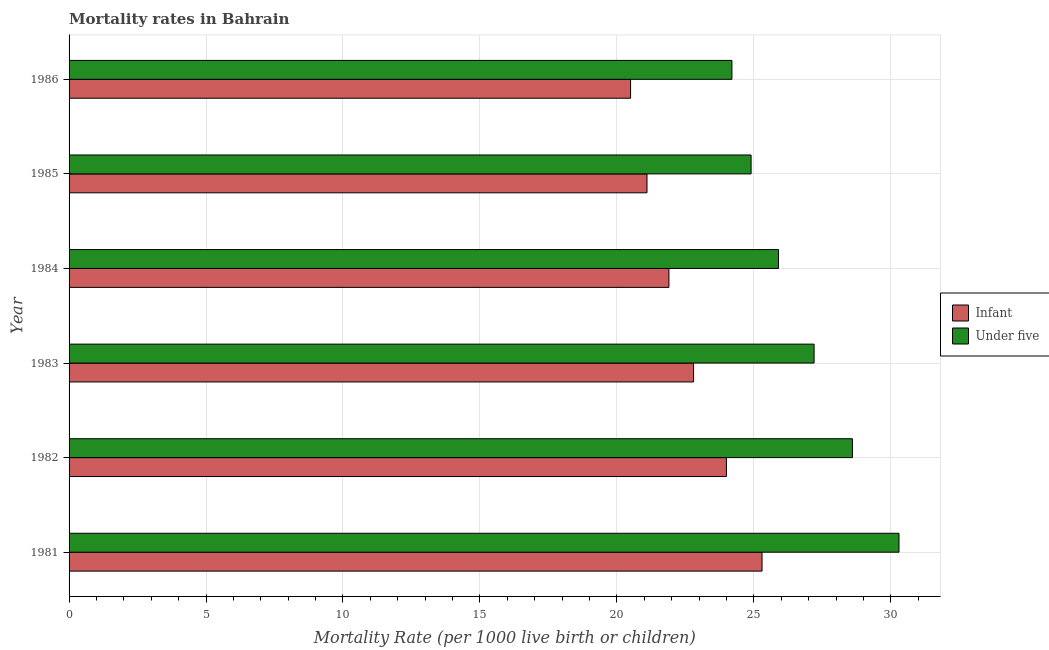How many different coloured bars are there?
Offer a terse response. 2. Are the number of bars per tick equal to the number of legend labels?
Offer a very short reply. Yes. Are the number of bars on each tick of the Y-axis equal?
Ensure brevity in your answer.  Yes. What is the label of the 5th group of bars from the top?
Provide a short and direct response. 1982. What is the under-5 mortality rate in 1982?
Offer a terse response. 28.6. Across all years, what is the maximum infant mortality rate?
Provide a short and direct response. 25.3. Across all years, what is the minimum under-5 mortality rate?
Your response must be concise. 24.2. In which year was the infant mortality rate maximum?
Make the answer very short. 1981. In which year was the under-5 mortality rate minimum?
Make the answer very short. 1986. What is the total infant mortality rate in the graph?
Make the answer very short. 135.6. What is the difference between the under-5 mortality rate in 1985 and that in 1986?
Provide a short and direct response. 0.7. What is the difference between the under-5 mortality rate in 1984 and the infant mortality rate in 1982?
Your answer should be very brief. 1.9. What is the average infant mortality rate per year?
Make the answer very short. 22.6. In how many years, is the infant mortality rate greater than 20 ?
Give a very brief answer. 6. What is the ratio of the infant mortality rate in 1981 to that in 1982?
Your answer should be very brief. 1.05. What is the difference between the highest and the second highest infant mortality rate?
Your response must be concise. 1.3. Is the sum of the infant mortality rate in 1983 and 1985 greater than the maximum under-5 mortality rate across all years?
Offer a very short reply. Yes. What does the 2nd bar from the top in 1981 represents?
Your answer should be compact. Infant. What does the 1st bar from the bottom in 1986 represents?
Give a very brief answer. Infant. What is the difference between two consecutive major ticks on the X-axis?
Make the answer very short. 5. Are the values on the major ticks of X-axis written in scientific E-notation?
Your answer should be compact. No. Does the graph contain grids?
Provide a short and direct response. Yes. Where does the legend appear in the graph?
Provide a succinct answer. Center right. How are the legend labels stacked?
Give a very brief answer. Vertical. What is the title of the graph?
Provide a short and direct response. Mortality rates in Bahrain. What is the label or title of the X-axis?
Your answer should be very brief. Mortality Rate (per 1000 live birth or children). What is the Mortality Rate (per 1000 live birth or children) of Infant in 1981?
Your response must be concise. 25.3. What is the Mortality Rate (per 1000 live birth or children) of Under five in 1981?
Ensure brevity in your answer.  30.3. What is the Mortality Rate (per 1000 live birth or children) of Infant in 1982?
Provide a succinct answer. 24. What is the Mortality Rate (per 1000 live birth or children) of Under five in 1982?
Your response must be concise. 28.6. What is the Mortality Rate (per 1000 live birth or children) in Infant in 1983?
Your answer should be very brief. 22.8. What is the Mortality Rate (per 1000 live birth or children) in Under five in 1983?
Ensure brevity in your answer.  27.2. What is the Mortality Rate (per 1000 live birth or children) of Infant in 1984?
Provide a succinct answer. 21.9. What is the Mortality Rate (per 1000 live birth or children) in Under five in 1984?
Make the answer very short. 25.9. What is the Mortality Rate (per 1000 live birth or children) in Infant in 1985?
Your answer should be very brief. 21.1. What is the Mortality Rate (per 1000 live birth or children) of Under five in 1985?
Keep it short and to the point. 24.9. What is the Mortality Rate (per 1000 live birth or children) of Under five in 1986?
Your answer should be very brief. 24.2. Across all years, what is the maximum Mortality Rate (per 1000 live birth or children) in Infant?
Make the answer very short. 25.3. Across all years, what is the maximum Mortality Rate (per 1000 live birth or children) in Under five?
Provide a succinct answer. 30.3. Across all years, what is the minimum Mortality Rate (per 1000 live birth or children) of Infant?
Ensure brevity in your answer.  20.5. Across all years, what is the minimum Mortality Rate (per 1000 live birth or children) in Under five?
Make the answer very short. 24.2. What is the total Mortality Rate (per 1000 live birth or children) in Infant in the graph?
Provide a succinct answer. 135.6. What is the total Mortality Rate (per 1000 live birth or children) in Under five in the graph?
Provide a short and direct response. 161.1. What is the difference between the Mortality Rate (per 1000 live birth or children) of Under five in 1981 and that in 1984?
Provide a succinct answer. 4.4. What is the difference between the Mortality Rate (per 1000 live birth or children) in Infant in 1981 and that in 1985?
Give a very brief answer. 4.2. What is the difference between the Mortality Rate (per 1000 live birth or children) in Infant in 1981 and that in 1986?
Give a very brief answer. 4.8. What is the difference between the Mortality Rate (per 1000 live birth or children) in Infant in 1982 and that in 1984?
Your answer should be compact. 2.1. What is the difference between the Mortality Rate (per 1000 live birth or children) in Under five in 1982 and that in 1984?
Provide a short and direct response. 2.7. What is the difference between the Mortality Rate (per 1000 live birth or children) in Under five in 1982 and that in 1985?
Your answer should be very brief. 3.7. What is the difference between the Mortality Rate (per 1000 live birth or children) of Infant in 1983 and that in 1984?
Your response must be concise. 0.9. What is the difference between the Mortality Rate (per 1000 live birth or children) in Infant in 1983 and that in 1985?
Provide a short and direct response. 1.7. What is the difference between the Mortality Rate (per 1000 live birth or children) of Under five in 1983 and that in 1986?
Give a very brief answer. 3. What is the difference between the Mortality Rate (per 1000 live birth or children) in Infant in 1984 and that in 1986?
Your answer should be very brief. 1.4. What is the difference between the Mortality Rate (per 1000 live birth or children) in Under five in 1984 and that in 1986?
Offer a very short reply. 1.7. What is the difference between the Mortality Rate (per 1000 live birth or children) in Under five in 1985 and that in 1986?
Your response must be concise. 0.7. What is the difference between the Mortality Rate (per 1000 live birth or children) in Infant in 1981 and the Mortality Rate (per 1000 live birth or children) in Under five in 1982?
Provide a short and direct response. -3.3. What is the difference between the Mortality Rate (per 1000 live birth or children) of Infant in 1981 and the Mortality Rate (per 1000 live birth or children) of Under five in 1985?
Give a very brief answer. 0.4. What is the difference between the Mortality Rate (per 1000 live birth or children) of Infant in 1982 and the Mortality Rate (per 1000 live birth or children) of Under five in 1984?
Your response must be concise. -1.9. What is the difference between the Mortality Rate (per 1000 live birth or children) in Infant in 1982 and the Mortality Rate (per 1000 live birth or children) in Under five in 1985?
Make the answer very short. -0.9. What is the difference between the Mortality Rate (per 1000 live birth or children) in Infant in 1982 and the Mortality Rate (per 1000 live birth or children) in Under five in 1986?
Your answer should be compact. -0.2. What is the average Mortality Rate (per 1000 live birth or children) of Infant per year?
Provide a succinct answer. 22.6. What is the average Mortality Rate (per 1000 live birth or children) in Under five per year?
Ensure brevity in your answer.  26.85. In the year 1981, what is the difference between the Mortality Rate (per 1000 live birth or children) in Infant and Mortality Rate (per 1000 live birth or children) in Under five?
Provide a short and direct response. -5. In the year 1985, what is the difference between the Mortality Rate (per 1000 live birth or children) of Infant and Mortality Rate (per 1000 live birth or children) of Under five?
Your answer should be very brief. -3.8. In the year 1986, what is the difference between the Mortality Rate (per 1000 live birth or children) of Infant and Mortality Rate (per 1000 live birth or children) of Under five?
Your answer should be compact. -3.7. What is the ratio of the Mortality Rate (per 1000 live birth or children) of Infant in 1981 to that in 1982?
Your response must be concise. 1.05. What is the ratio of the Mortality Rate (per 1000 live birth or children) of Under five in 1981 to that in 1982?
Offer a very short reply. 1.06. What is the ratio of the Mortality Rate (per 1000 live birth or children) in Infant in 1981 to that in 1983?
Your answer should be compact. 1.11. What is the ratio of the Mortality Rate (per 1000 live birth or children) of Under five in 1981 to that in 1983?
Offer a terse response. 1.11. What is the ratio of the Mortality Rate (per 1000 live birth or children) in Infant in 1981 to that in 1984?
Your answer should be very brief. 1.16. What is the ratio of the Mortality Rate (per 1000 live birth or children) in Under five in 1981 to that in 1984?
Provide a short and direct response. 1.17. What is the ratio of the Mortality Rate (per 1000 live birth or children) of Infant in 1981 to that in 1985?
Your answer should be very brief. 1.2. What is the ratio of the Mortality Rate (per 1000 live birth or children) in Under five in 1981 to that in 1985?
Offer a terse response. 1.22. What is the ratio of the Mortality Rate (per 1000 live birth or children) of Infant in 1981 to that in 1986?
Give a very brief answer. 1.23. What is the ratio of the Mortality Rate (per 1000 live birth or children) in Under five in 1981 to that in 1986?
Your response must be concise. 1.25. What is the ratio of the Mortality Rate (per 1000 live birth or children) in Infant in 1982 to that in 1983?
Give a very brief answer. 1.05. What is the ratio of the Mortality Rate (per 1000 live birth or children) of Under five in 1982 to that in 1983?
Your answer should be compact. 1.05. What is the ratio of the Mortality Rate (per 1000 live birth or children) of Infant in 1982 to that in 1984?
Give a very brief answer. 1.1. What is the ratio of the Mortality Rate (per 1000 live birth or children) of Under five in 1982 to that in 1984?
Offer a very short reply. 1.1. What is the ratio of the Mortality Rate (per 1000 live birth or children) in Infant in 1982 to that in 1985?
Your answer should be very brief. 1.14. What is the ratio of the Mortality Rate (per 1000 live birth or children) of Under five in 1982 to that in 1985?
Offer a terse response. 1.15. What is the ratio of the Mortality Rate (per 1000 live birth or children) of Infant in 1982 to that in 1986?
Provide a short and direct response. 1.17. What is the ratio of the Mortality Rate (per 1000 live birth or children) of Under five in 1982 to that in 1986?
Ensure brevity in your answer.  1.18. What is the ratio of the Mortality Rate (per 1000 live birth or children) in Infant in 1983 to that in 1984?
Provide a short and direct response. 1.04. What is the ratio of the Mortality Rate (per 1000 live birth or children) in Under five in 1983 to that in 1984?
Ensure brevity in your answer.  1.05. What is the ratio of the Mortality Rate (per 1000 live birth or children) of Infant in 1983 to that in 1985?
Keep it short and to the point. 1.08. What is the ratio of the Mortality Rate (per 1000 live birth or children) in Under five in 1983 to that in 1985?
Offer a terse response. 1.09. What is the ratio of the Mortality Rate (per 1000 live birth or children) in Infant in 1983 to that in 1986?
Provide a succinct answer. 1.11. What is the ratio of the Mortality Rate (per 1000 live birth or children) in Under five in 1983 to that in 1986?
Provide a succinct answer. 1.12. What is the ratio of the Mortality Rate (per 1000 live birth or children) in Infant in 1984 to that in 1985?
Provide a short and direct response. 1.04. What is the ratio of the Mortality Rate (per 1000 live birth or children) of Under five in 1984 to that in 1985?
Your answer should be compact. 1.04. What is the ratio of the Mortality Rate (per 1000 live birth or children) of Infant in 1984 to that in 1986?
Your answer should be very brief. 1.07. What is the ratio of the Mortality Rate (per 1000 live birth or children) in Under five in 1984 to that in 1986?
Make the answer very short. 1.07. What is the ratio of the Mortality Rate (per 1000 live birth or children) of Infant in 1985 to that in 1986?
Offer a very short reply. 1.03. What is the ratio of the Mortality Rate (per 1000 live birth or children) in Under five in 1985 to that in 1986?
Make the answer very short. 1.03. What is the difference between the highest and the second highest Mortality Rate (per 1000 live birth or children) of Infant?
Provide a short and direct response. 1.3. What is the difference between the highest and the lowest Mortality Rate (per 1000 live birth or children) in Under five?
Provide a short and direct response. 6.1. 